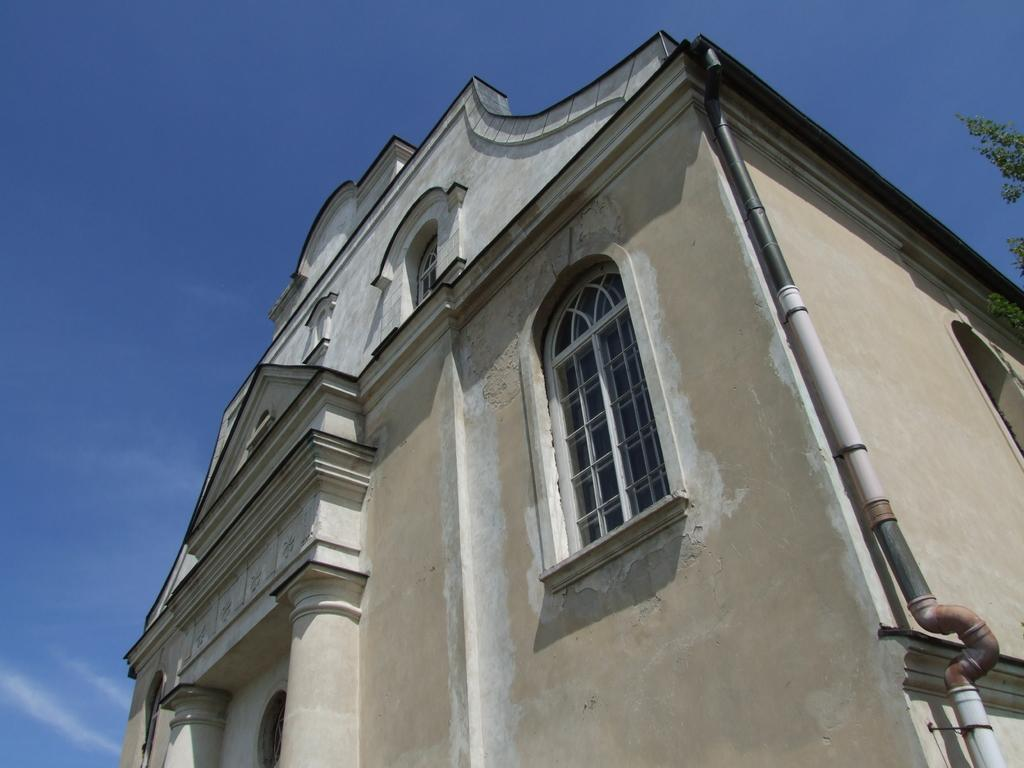What type of structure is present in the image? There is a building in the image. What feature can be seen on the building? The building has a window. What is visible at the top of the image? The sky is visible at the top of the image. What type of vegetation is on the right side of the image? There is a tree on the right side of the image. What is attached to the building? There is a pipe attached to the building. What type of question is being asked by the jar in the image? There is no jar present in the image, and therefore no question is being asked. 